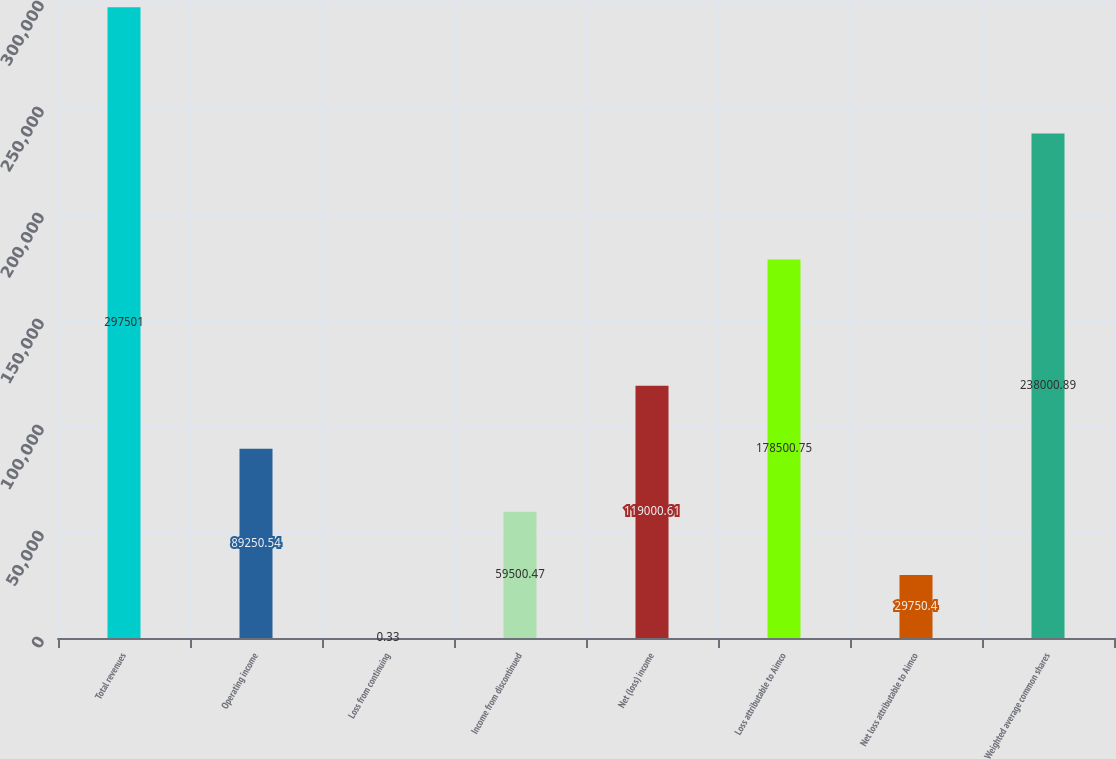<chart> <loc_0><loc_0><loc_500><loc_500><bar_chart><fcel>Total revenues<fcel>Operating income<fcel>Loss from continuing<fcel>Income from discontinued<fcel>Net (loss) income<fcel>Loss attributable to Aimco<fcel>Net loss attributable to Aimco<fcel>Weighted average common shares<nl><fcel>297501<fcel>89250.5<fcel>0.33<fcel>59500.5<fcel>119001<fcel>178501<fcel>29750.4<fcel>238001<nl></chart> 